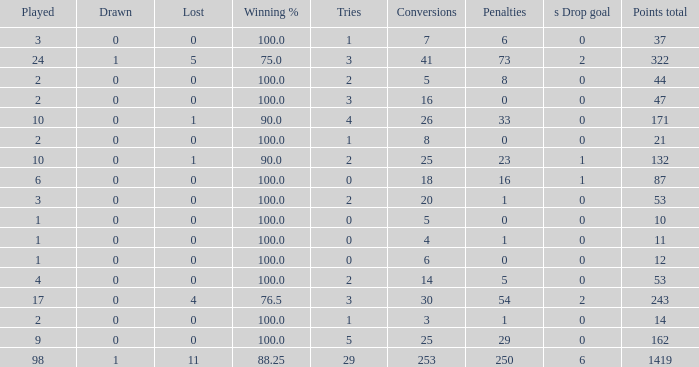When he had 1 penalty and over 20 conversions, how many ties did he possess? None. 